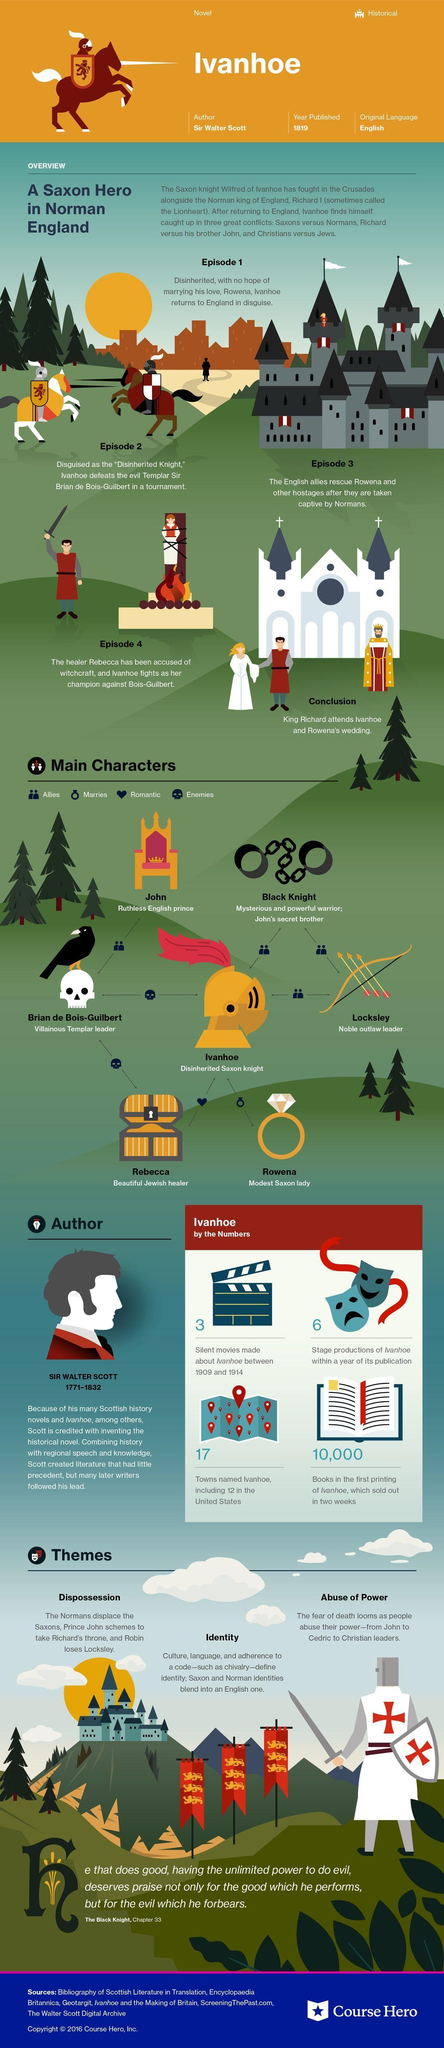Outline some significant characteristics in this image. The name of the hard English prince is John. There are 5 cities named after the character Ivanhoe, excluding the 12 in the United States. John has allies, specifically Brian de Bois-Guilbert, who supports and helps him. Ivanhoe wins the fight against Brian in episode 2. The allies of Ivanhoe are the Black Knight and Locksley. 